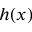<formula> <loc_0><loc_0><loc_500><loc_500>h ( x )</formula> 